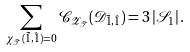Convert formula to latex. <formula><loc_0><loc_0><loc_500><loc_500>\sum _ { \chi _ { \mathcal { T } } ( \tilde { 1 } , \hat { 1 } ) = 0 } { \mathcal { C } } _ { { \mathcal { Z } } _ { \mathcal { T } } } ( { \mathcal { D } } _ { \tilde { 1 } , \hat { 1 } } ) = 3 \left | { \mathcal { S } } _ { 1 } \right | .</formula> 